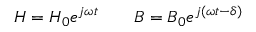Convert formula to latex. <formula><loc_0><loc_0><loc_500><loc_500>H = H _ { 0 } e ^ { j \omega t } \quad B = B _ { 0 } e ^ { j \left ( \omega t - \delta \right ) }</formula> 